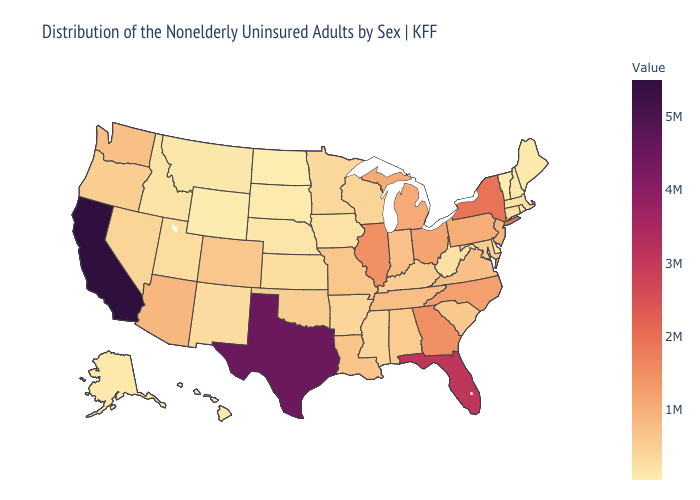Which states hav the highest value in the South?
Quick response, please. Texas. Among the states that border Mississippi , does Arkansas have the lowest value?
Quick response, please. Yes. Which states hav the highest value in the West?
Short answer required. California. Does Illinois have a higher value than Massachusetts?
Be succinct. Yes. Does New Hampshire have the highest value in the USA?
Write a very short answer. No. Among the states that border New York , does Pennsylvania have the lowest value?
Write a very short answer. No. 